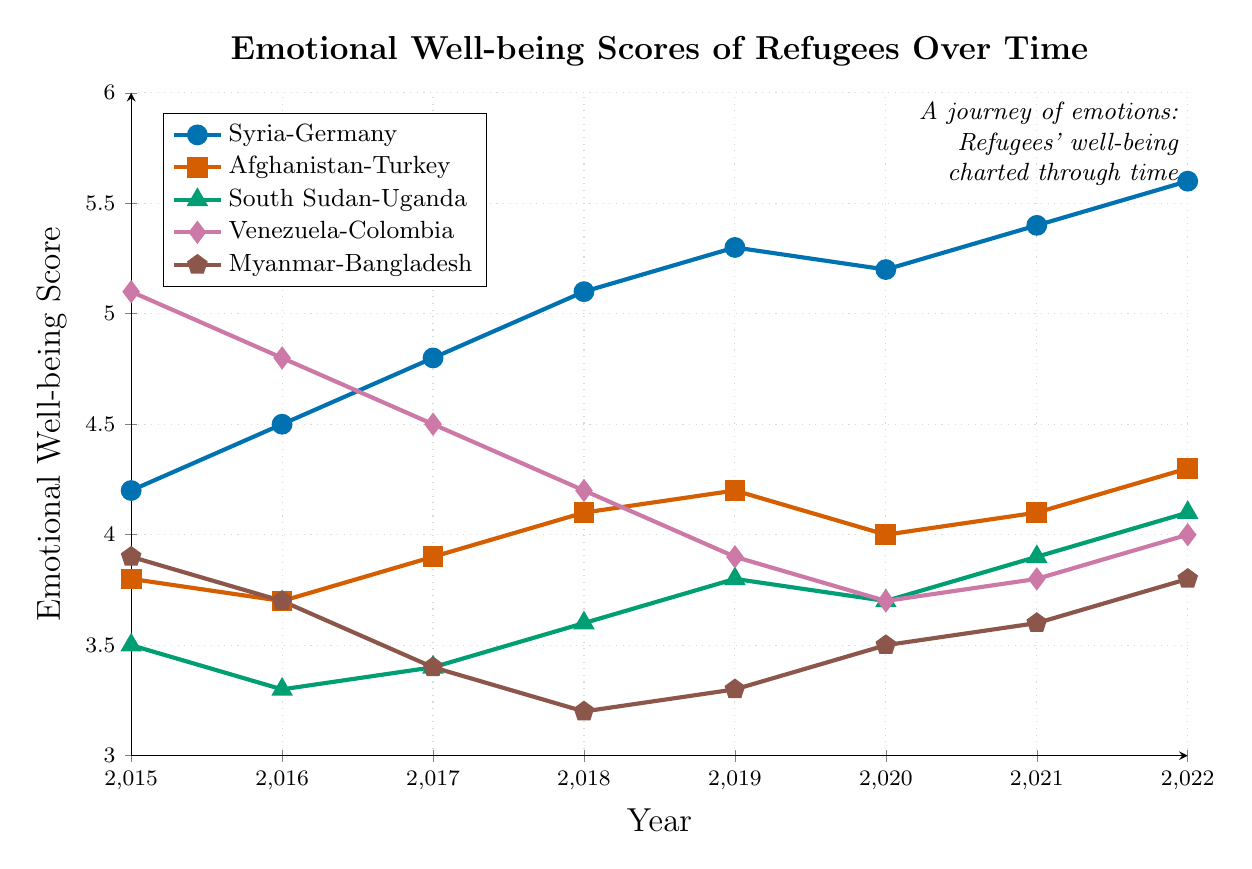What's the difference in emotional well-being scores for Syria-Germany between 2015 and 2022? The score in 2015 for Syria-Germany is 4.2 and in 2022 it is 5.6. The difference is calculated as 5.6 - 4.2.
Answer: 1.4 Between which years did Afghanistan-Turkey see the greatest increase in emotional well-being scores? Checking the increases year by year: 2016-2017 (3.7 to 3.9 = 0.2), 2017-2018 (3.9 to 4.1 = 0.2), 2018-2019 (4.1 to 4.2 = 0.1), 2021-2022 (4.1 to 4.3 = 0.2), and 2019-2020 (4.2 to 4.0 = -0.2), the greatest increase is 2015-2016 (3.8 to 3.7 which is a decrease). Another increase occurs from 2020 to 2021 (4.0 to 4.1 = 0.1). So the greatest increase is between 2017 and 2018.
Answer: 2017-2018, 0.2 Which host country reflects the highest emotional well-being score in 2022? Looking at the scores in 2022: Syria-Germany (5.6), Afghanistan-Turkey (4.3), South Sudan-Uganda (4.1), Venezuela-Colombia (4.0), and Myanmar-Bangladesh (3.8), Syria-Germany has the highest score.
Answer: Syria-Germany How did the emotional well-being scores for Venezuela-Colombia change over the years? The scores for Venezuela-Colombia are: 2015 (5.1), 2016 (4.8), 2017 (4.5), 2018 (4.2), 2019 (3.9), 2020 (3.7), 2021 (3.8), and 2022 (4.0). The trend shows a decrease from 2015 to 2020 and then a slight increase from 2020 to 2022.
Answer: Decreased then slightly increased Which pairing showed a steady increase in emotional well-being scores without any decrease from 2015 to 2022? Syria-Germany scores: 2015 (4.2), 2016 (4.5), 2017 (4.8), 2018 (5.1), 2019 (5.3), 2020 (5.2), 2021 (5.4), 2022 (5.6). Afghanistan-Turkey scores: 2015 (3.8), 2016 (3.7), 2017 (3.9), 2018 (4.1), 2019 (4.2), 2020 (4.0), 2021 (4.1), 2022 (4.3). South Sudan-Uganda scores: 2015 (3.5), 2016 (3.3), 2017 (3.4), 2018 (3.6), 2019 (3.8), 2020 (3.7), 2021 (3.9), 2022 (4.1). Venezuela-Colombia scores: 2015 (5.1), 2016 (4.8), 2017 (4.5), 2018 (4.2), 2019 (3.9), 2020 (3.7), 2021 (3.8), 2022 (4.0). Myanmar-Bangladesh scores: 2015 (3.9), 2016 (3.7), 2017 (3.4), 2018 (3.2), 2019 (3.3), 2020 (3.5), 2021 (3.6), 2022 (3.8). Only Syria-Germany shows a steady increase without any decreases.
Answer: Syria-Germany What is the average emotional well-being score for South Sudan-Uganda over the given years? The scores are 2015 (3.5), 2016 (3.3), 2017 (3.4), 2018 (3.6), 2019 (3.8), 2020 (3.7), 2021 (3.9), and 2022 (4.1). Summing these gives 29.3. Dividing by the number of years (8) gives 29.3/8.
Answer: 3.6625 Which two countries have the most similar emotional well-being scores in 2020? The scores in 2020 are Syria-Germany (5.2), Afghanistan-Turkey (4.0), South Sudan-Uganda (3.7), Venezuela-Colombia (3.7), Myanmar-Bangladesh (3.5). South Sudan-Uganda and Venezuela-Colombia have the most similar scores.
Answer: South Sudan-Uganda and Venezuela-Colombia 